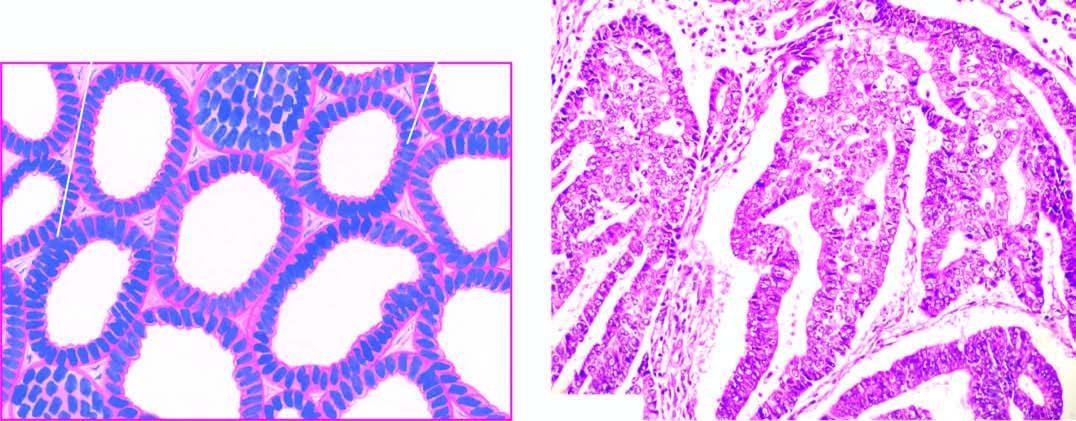re defects in any of the six well-differentiated adenocarcinoma showing closely packed glands with cytologic atypia?
Answer the question using a single word or phrase. No 